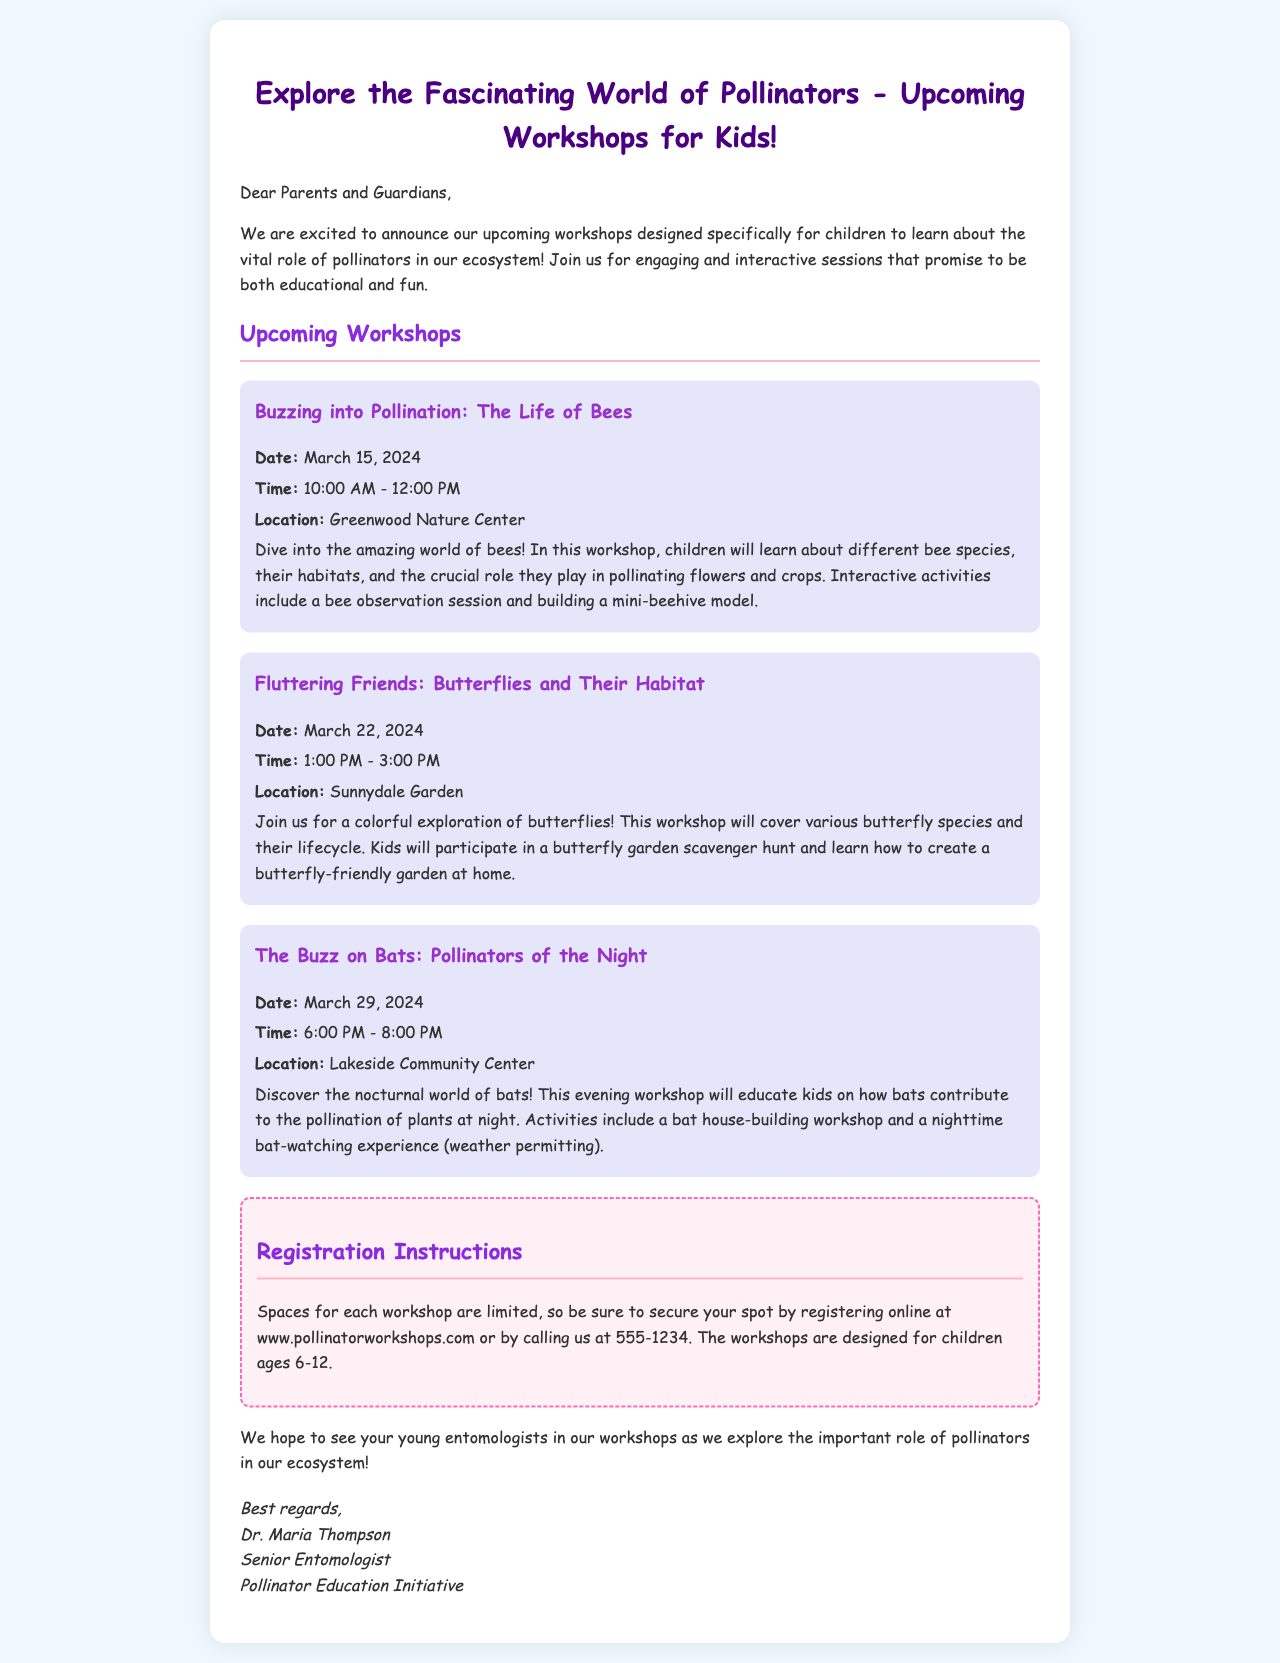what is the title of the first workshop? The title of the first workshop is explicitly stated in the document as "Buzzing into Pollination: The Life of Bees."
Answer: Buzzing into Pollination: The Life of Bees when is the butterfly workshop scheduled? The butterfly workshop date is clearly mentioned as March 22, 2024.
Answer: March 22, 2024 where will the bat workshop take place? The location for the bat workshop is provided in the document as Lakeside Community Center.
Answer: Lakeside Community Center how long is the bee workshop? The duration of the bee workshop is indicated as 2 hours, from 10:00 AM to 12:00 PM.
Answer: 2 hours who is the organizer of the workshops? The organizer is identified in the closing signature of the email as Dr. Maria Thompson.
Answer: Dr. Maria Thompson what age group are the workshops designed for? The target age group for the workshops is noted as children ages 6-12.
Answer: ages 6-12 how can parents register for the workshops? Registration instructions specify that parents can register online or by calling a provided number.
Answer: online at www.pollinatorworkshops.com or by calling us at 555-1234 what activity is included in the bat workshop? The document mentions a specific activity, "bat house-building workshop," as part of the bat workshop.
Answer: bat house-building workshop what color is the background of the email? The background color of the email is provided as light blue (#F0F8FF).
Answer: light blue 